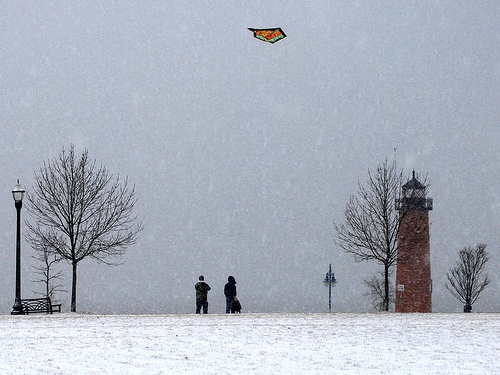Describe the objects in this image and their specific colors. I can see bench in darkgray, black, gray, and lightgray tones, people in darkgray, black, gray, and navy tones, people in darkgray, black, and gray tones, kite in darkgray, black, gray, red, and brown tones, and backpack in darkgray, black, and gray tones in this image. 